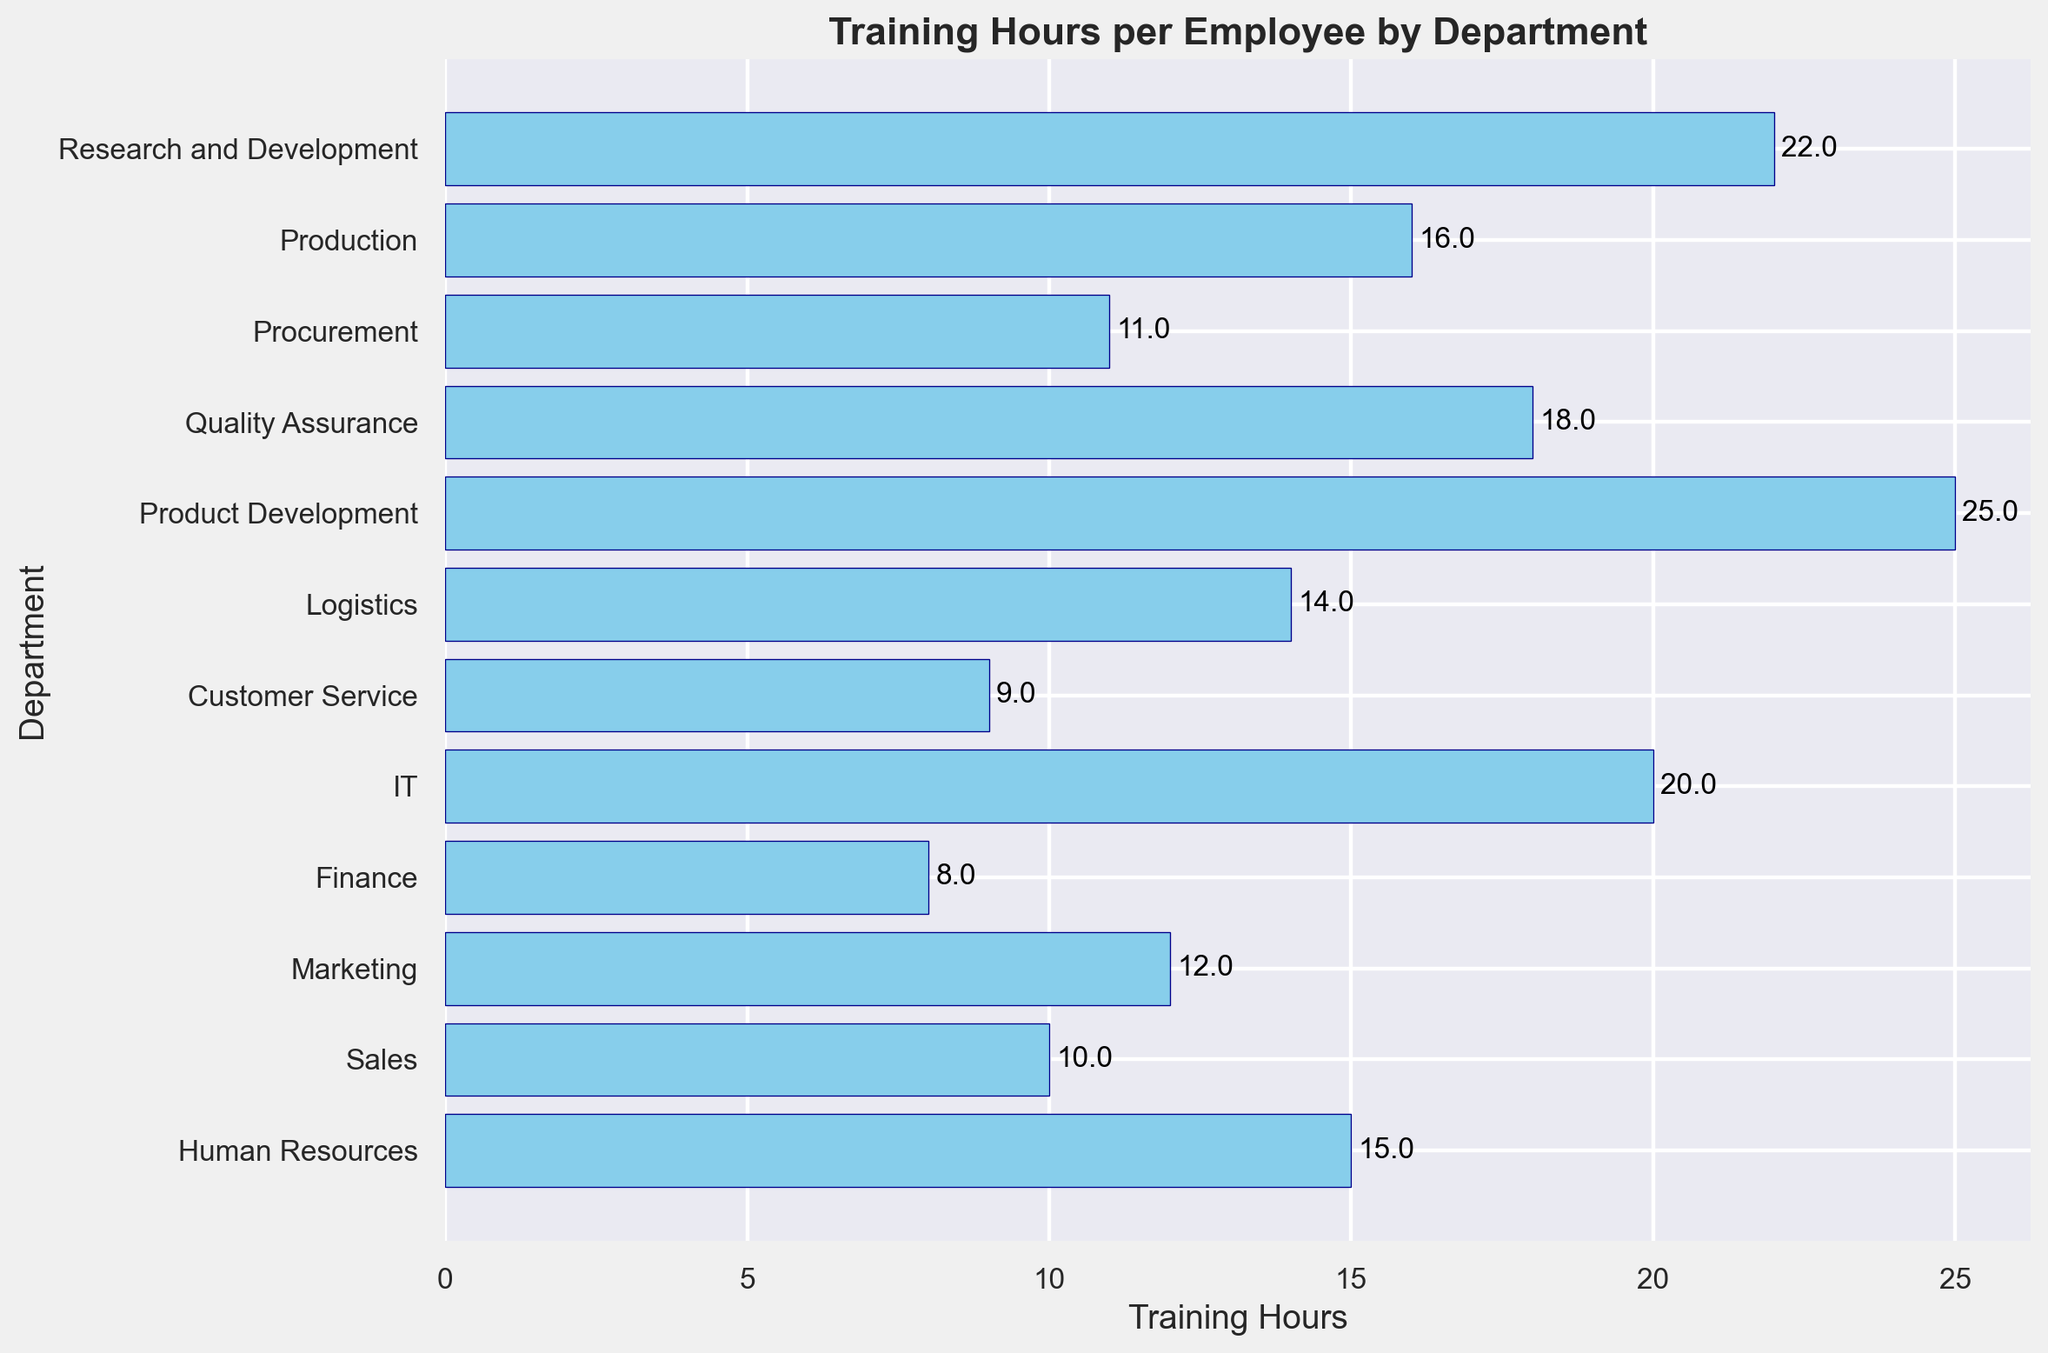What department has the highest training hours per employee? The bar for Product Development is the longest, indicating it has the highest training hours per employee.
Answer: Product Development How much more training does the Research and Development department receive compared to the Marketing department? The chart shows that Research and Development has 22 hours, and Marketing has 12 hours. The difference is 22 - 12 = 10 hours.
Answer: 10 hours Which departments have training hours per employee greater than 15? The departments with bars extending beyond the 15-hour mark are Production, Research and Development, Quality Assurance, IT, and Product Development.
Answer: Production, Research and Development, Quality Assurance, IT, Product Development What is the total number of training hours per employee for Sales and Customer Service combined? Sales has 10 hours, and Customer Service has 9 hours. The total is 10 + 9 = 19 hours.
Answer: 19 hours What is the average training hours per employee across all departments? Sum all training hours: 15 + 10 + 12 + 8 + 20 + 9 + 14 + 25 + 18 + 11 + 16 + 22 = 180 hours. There are 12 departments, so the average is 180 / 12 = 15 hours.
Answer: 15 hours Which department has the least training hours per employee, and how many hours is that? The bar for Finance is the shortest, indicating it has the least training hours per employee, which is 8 hours.
Answer: Finance, 8 hours Compare the training hours per employee between Quality Assurance and Procurement. Which one has more, and by how much? Quality Assurance has 18 hours, and Procurement has 11 hours. The difference is 18 - 11 = 7 hours.
Answer: Quality Assurance, 7 hours What is the median training hours per employee across all departments? When ordered (8, 9, 10, 11, 12, 14, 15, 16, 18, 20, 22, 25), the middle values are 14 and 15. The median is (14 + 15) / 2 = 14.5 hours.
Answer: 14.5 hours How many departments have training hours less than 10? The bars for Finance (8 hours) and Customer Service (9 hours) are less than 10 hours.
Answer: 2 departments Which department is immediately above Sales in terms of training hours, and how many hours is that? According to the bars, Procurement with 11 hours is immediately above Sales, which has 10 hours.
Answer: Procurement, 11 hours 